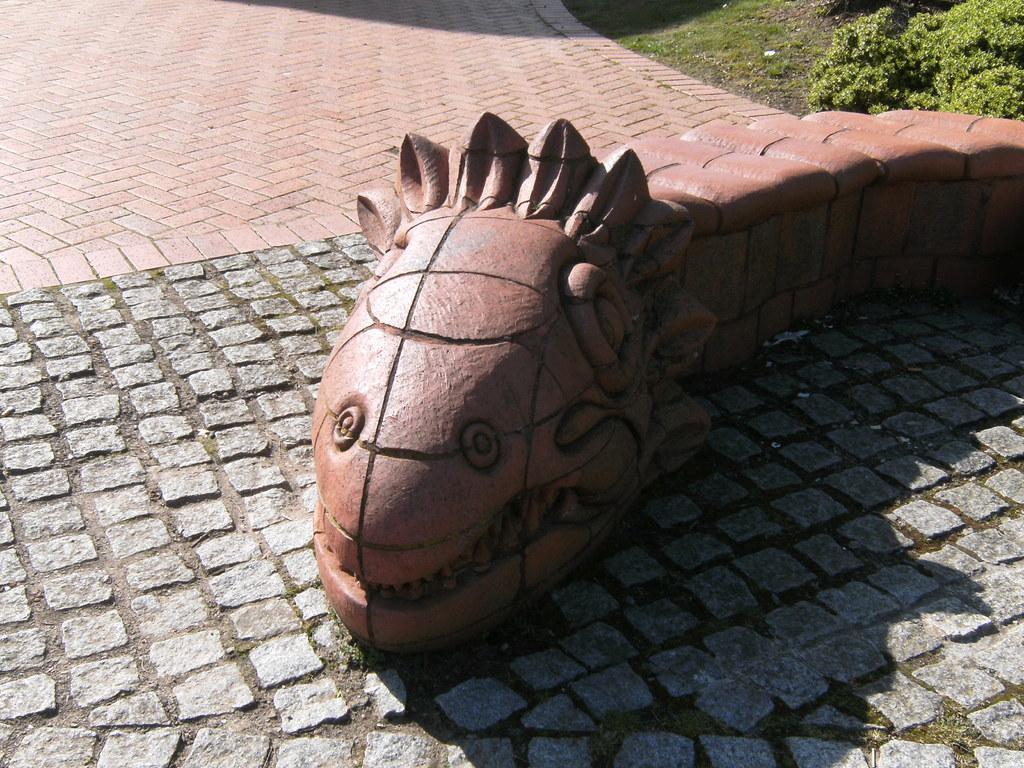Please provide a concise description of this image. In this image we can see cobblestone which is in brown color, in the foreground of the image there is foundation which is in brown color is in the shape of snake and in the background of the image there are some plants and grass. 